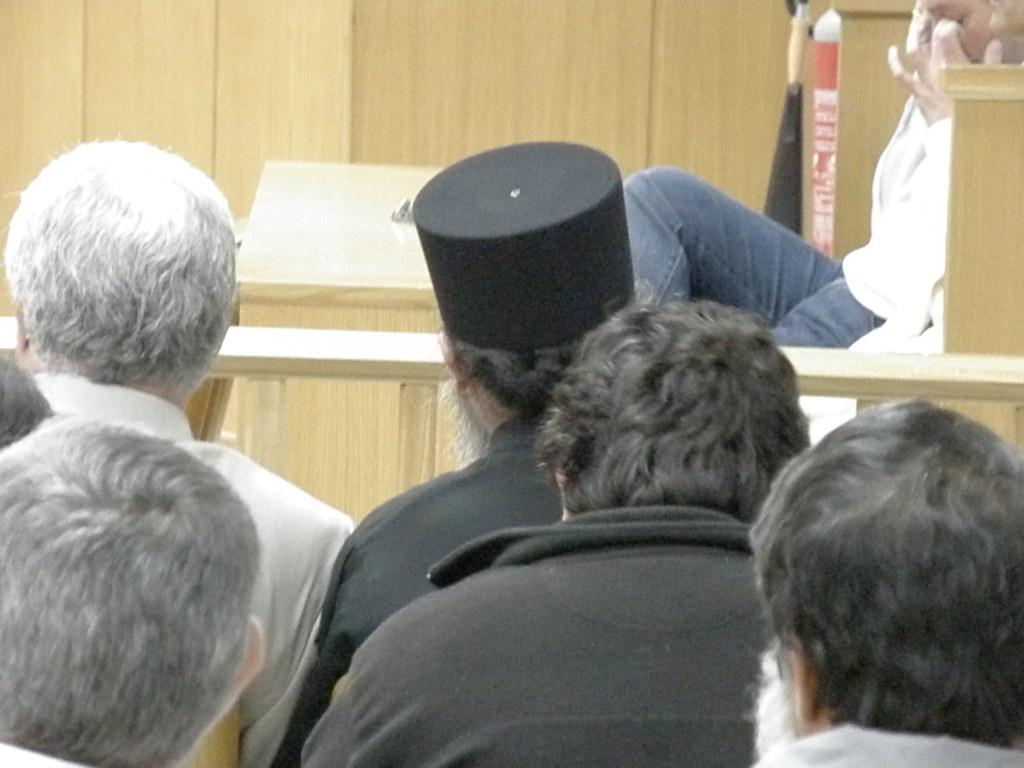Who or what can be seen in the image? There are people in the image. Can you describe the background of the image? There is a cream-colored object in the background of the image. What type of competition is taking place in the image? There is no competition present in the image; it only features people and a cream-colored object in the background. How many ducks are visible in the image? There are no ducks present in the image. 